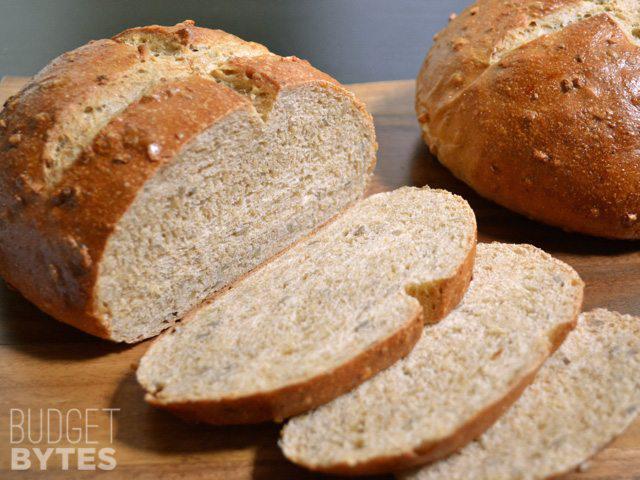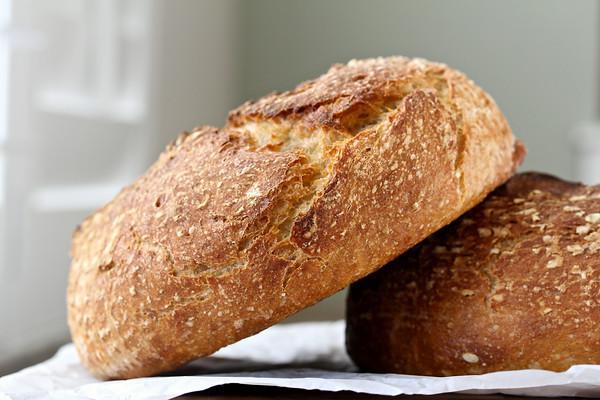The first image is the image on the left, the second image is the image on the right. Assess this claim about the two images: "The left image includes at least two slices of bread overlapping in front of a cut loaf, and the right image shows one flat-bottomed round bread leaning against one that is sitting flat.". Correct or not? Answer yes or no. Yes. The first image is the image on the left, the second image is the image on the right. For the images shown, is this caption "The bread in the image on the left has already been sliced." true? Answer yes or no. Yes. 